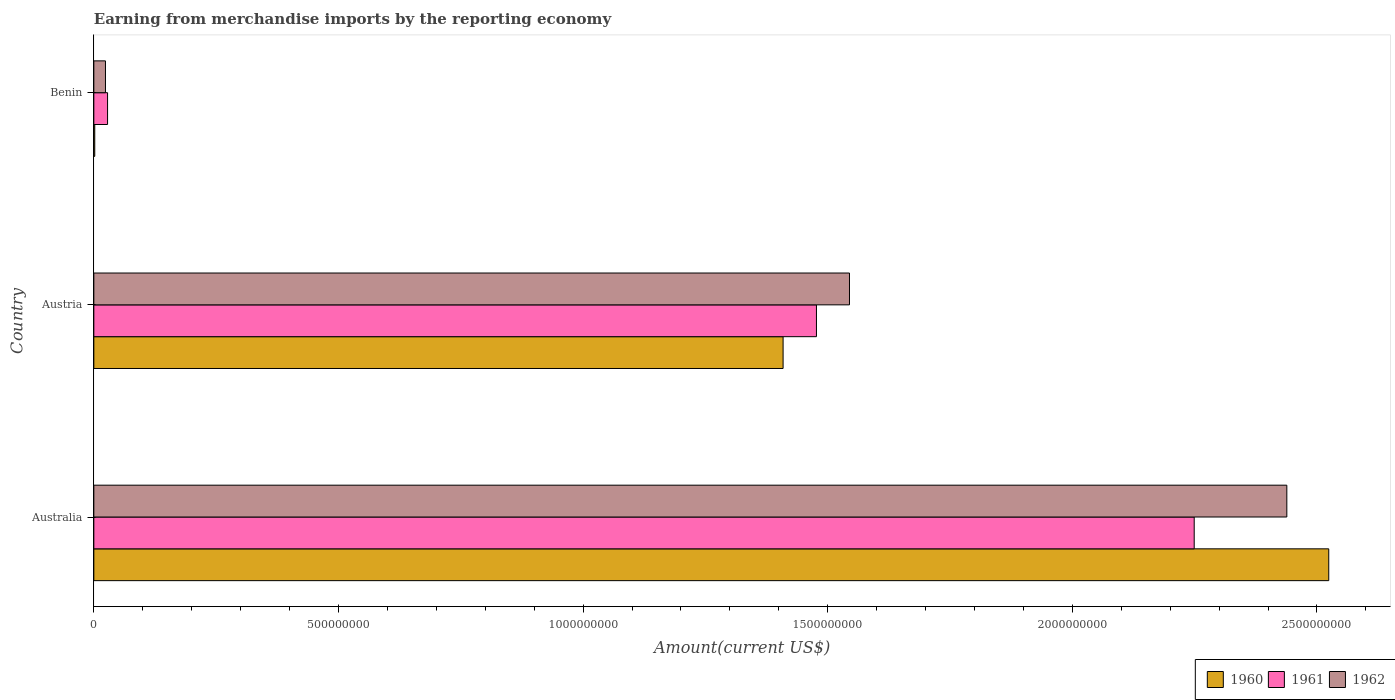Are the number of bars on each tick of the Y-axis equal?
Make the answer very short. Yes. How many bars are there on the 3rd tick from the top?
Provide a short and direct response. 3. How many bars are there on the 1st tick from the bottom?
Provide a succinct answer. 3. What is the label of the 2nd group of bars from the top?
Offer a very short reply. Austria. What is the amount earned from merchandise imports in 1961 in Benin?
Your response must be concise. 2.81e+07. Across all countries, what is the maximum amount earned from merchandise imports in 1962?
Offer a very short reply. 2.44e+09. Across all countries, what is the minimum amount earned from merchandise imports in 1961?
Provide a succinct answer. 2.81e+07. In which country was the amount earned from merchandise imports in 1960 maximum?
Give a very brief answer. Australia. In which country was the amount earned from merchandise imports in 1960 minimum?
Offer a very short reply. Benin. What is the total amount earned from merchandise imports in 1960 in the graph?
Ensure brevity in your answer.  3.93e+09. What is the difference between the amount earned from merchandise imports in 1962 in Australia and that in Benin?
Your answer should be very brief. 2.41e+09. What is the difference between the amount earned from merchandise imports in 1960 in Benin and the amount earned from merchandise imports in 1961 in Australia?
Provide a succinct answer. -2.25e+09. What is the average amount earned from merchandise imports in 1962 per country?
Ensure brevity in your answer.  1.34e+09. What is the difference between the amount earned from merchandise imports in 1961 and amount earned from merchandise imports in 1960 in Benin?
Your answer should be compact. 2.62e+07. In how many countries, is the amount earned from merchandise imports in 1961 greater than 200000000 US$?
Offer a terse response. 2. What is the ratio of the amount earned from merchandise imports in 1961 in Australia to that in Austria?
Provide a succinct answer. 1.52. Is the difference between the amount earned from merchandise imports in 1961 in Australia and Austria greater than the difference between the amount earned from merchandise imports in 1960 in Australia and Austria?
Your answer should be compact. No. What is the difference between the highest and the second highest amount earned from merchandise imports in 1960?
Your response must be concise. 1.12e+09. What is the difference between the highest and the lowest amount earned from merchandise imports in 1961?
Offer a terse response. 2.22e+09. Is the sum of the amount earned from merchandise imports in 1960 in Australia and Austria greater than the maximum amount earned from merchandise imports in 1961 across all countries?
Offer a terse response. Yes. Is it the case that in every country, the sum of the amount earned from merchandise imports in 1962 and amount earned from merchandise imports in 1960 is greater than the amount earned from merchandise imports in 1961?
Make the answer very short. No. What is the difference between two consecutive major ticks on the X-axis?
Keep it short and to the point. 5.00e+08. Where does the legend appear in the graph?
Keep it short and to the point. Bottom right. How many legend labels are there?
Keep it short and to the point. 3. How are the legend labels stacked?
Provide a short and direct response. Horizontal. What is the title of the graph?
Offer a very short reply. Earning from merchandise imports by the reporting economy. Does "1966" appear as one of the legend labels in the graph?
Your answer should be very brief. No. What is the label or title of the X-axis?
Provide a succinct answer. Amount(current US$). What is the Amount(current US$) in 1960 in Australia?
Offer a terse response. 2.52e+09. What is the Amount(current US$) in 1961 in Australia?
Provide a short and direct response. 2.25e+09. What is the Amount(current US$) in 1962 in Australia?
Give a very brief answer. 2.44e+09. What is the Amount(current US$) of 1960 in Austria?
Offer a very short reply. 1.41e+09. What is the Amount(current US$) of 1961 in Austria?
Make the answer very short. 1.48e+09. What is the Amount(current US$) of 1962 in Austria?
Your answer should be very brief. 1.54e+09. What is the Amount(current US$) in 1960 in Benin?
Provide a short and direct response. 1.90e+06. What is the Amount(current US$) of 1961 in Benin?
Ensure brevity in your answer.  2.81e+07. What is the Amount(current US$) of 1962 in Benin?
Give a very brief answer. 2.38e+07. Across all countries, what is the maximum Amount(current US$) of 1960?
Provide a short and direct response. 2.52e+09. Across all countries, what is the maximum Amount(current US$) of 1961?
Provide a succinct answer. 2.25e+09. Across all countries, what is the maximum Amount(current US$) in 1962?
Provide a succinct answer. 2.44e+09. Across all countries, what is the minimum Amount(current US$) of 1960?
Your response must be concise. 1.90e+06. Across all countries, what is the minimum Amount(current US$) in 1961?
Offer a very short reply. 2.81e+07. Across all countries, what is the minimum Amount(current US$) in 1962?
Provide a succinct answer. 2.38e+07. What is the total Amount(current US$) in 1960 in the graph?
Give a very brief answer. 3.93e+09. What is the total Amount(current US$) in 1961 in the graph?
Provide a succinct answer. 3.75e+09. What is the total Amount(current US$) in 1962 in the graph?
Your answer should be very brief. 4.01e+09. What is the difference between the Amount(current US$) of 1960 in Australia and that in Austria?
Make the answer very short. 1.12e+09. What is the difference between the Amount(current US$) of 1961 in Australia and that in Austria?
Make the answer very short. 7.72e+08. What is the difference between the Amount(current US$) of 1962 in Australia and that in Austria?
Your answer should be very brief. 8.94e+08. What is the difference between the Amount(current US$) of 1960 in Australia and that in Benin?
Provide a short and direct response. 2.52e+09. What is the difference between the Amount(current US$) of 1961 in Australia and that in Benin?
Ensure brevity in your answer.  2.22e+09. What is the difference between the Amount(current US$) of 1962 in Australia and that in Benin?
Make the answer very short. 2.41e+09. What is the difference between the Amount(current US$) in 1960 in Austria and that in Benin?
Keep it short and to the point. 1.41e+09. What is the difference between the Amount(current US$) of 1961 in Austria and that in Benin?
Provide a succinct answer. 1.45e+09. What is the difference between the Amount(current US$) in 1962 in Austria and that in Benin?
Make the answer very short. 1.52e+09. What is the difference between the Amount(current US$) in 1960 in Australia and the Amount(current US$) in 1961 in Austria?
Keep it short and to the point. 1.05e+09. What is the difference between the Amount(current US$) of 1960 in Australia and the Amount(current US$) of 1962 in Austria?
Keep it short and to the point. 9.80e+08. What is the difference between the Amount(current US$) in 1961 in Australia and the Amount(current US$) in 1962 in Austria?
Ensure brevity in your answer.  7.05e+08. What is the difference between the Amount(current US$) in 1960 in Australia and the Amount(current US$) in 1961 in Benin?
Give a very brief answer. 2.50e+09. What is the difference between the Amount(current US$) of 1960 in Australia and the Amount(current US$) of 1962 in Benin?
Your response must be concise. 2.50e+09. What is the difference between the Amount(current US$) in 1961 in Australia and the Amount(current US$) in 1962 in Benin?
Your answer should be very brief. 2.23e+09. What is the difference between the Amount(current US$) in 1960 in Austria and the Amount(current US$) in 1961 in Benin?
Offer a terse response. 1.38e+09. What is the difference between the Amount(current US$) in 1960 in Austria and the Amount(current US$) in 1962 in Benin?
Make the answer very short. 1.38e+09. What is the difference between the Amount(current US$) of 1961 in Austria and the Amount(current US$) of 1962 in Benin?
Make the answer very short. 1.45e+09. What is the average Amount(current US$) of 1960 per country?
Offer a terse response. 1.31e+09. What is the average Amount(current US$) of 1961 per country?
Ensure brevity in your answer.  1.25e+09. What is the average Amount(current US$) of 1962 per country?
Ensure brevity in your answer.  1.34e+09. What is the difference between the Amount(current US$) of 1960 and Amount(current US$) of 1961 in Australia?
Your answer should be compact. 2.75e+08. What is the difference between the Amount(current US$) in 1960 and Amount(current US$) in 1962 in Australia?
Make the answer very short. 8.57e+07. What is the difference between the Amount(current US$) in 1961 and Amount(current US$) in 1962 in Australia?
Your answer should be compact. -1.89e+08. What is the difference between the Amount(current US$) in 1960 and Amount(current US$) in 1961 in Austria?
Your answer should be compact. -6.82e+07. What is the difference between the Amount(current US$) of 1960 and Amount(current US$) of 1962 in Austria?
Make the answer very short. -1.36e+08. What is the difference between the Amount(current US$) in 1961 and Amount(current US$) in 1962 in Austria?
Provide a succinct answer. -6.75e+07. What is the difference between the Amount(current US$) in 1960 and Amount(current US$) in 1961 in Benin?
Provide a short and direct response. -2.62e+07. What is the difference between the Amount(current US$) in 1960 and Amount(current US$) in 1962 in Benin?
Keep it short and to the point. -2.19e+07. What is the difference between the Amount(current US$) in 1961 and Amount(current US$) in 1962 in Benin?
Offer a very short reply. 4.30e+06. What is the ratio of the Amount(current US$) in 1960 in Australia to that in Austria?
Your answer should be compact. 1.79. What is the ratio of the Amount(current US$) in 1961 in Australia to that in Austria?
Your answer should be very brief. 1.52. What is the ratio of the Amount(current US$) of 1962 in Australia to that in Austria?
Offer a terse response. 1.58. What is the ratio of the Amount(current US$) of 1960 in Australia to that in Benin?
Keep it short and to the point. 1328.45. What is the ratio of the Amount(current US$) of 1961 in Australia to that in Benin?
Keep it short and to the point. 80.04. What is the ratio of the Amount(current US$) of 1962 in Australia to that in Benin?
Ensure brevity in your answer.  102.45. What is the ratio of the Amount(current US$) of 1960 in Austria to that in Benin?
Keep it short and to the point. 741.47. What is the ratio of the Amount(current US$) in 1961 in Austria to that in Benin?
Give a very brief answer. 52.56. What is the ratio of the Amount(current US$) in 1962 in Austria to that in Benin?
Your answer should be very brief. 64.89. What is the difference between the highest and the second highest Amount(current US$) of 1960?
Your answer should be very brief. 1.12e+09. What is the difference between the highest and the second highest Amount(current US$) of 1961?
Make the answer very short. 7.72e+08. What is the difference between the highest and the second highest Amount(current US$) of 1962?
Provide a short and direct response. 8.94e+08. What is the difference between the highest and the lowest Amount(current US$) in 1960?
Ensure brevity in your answer.  2.52e+09. What is the difference between the highest and the lowest Amount(current US$) of 1961?
Give a very brief answer. 2.22e+09. What is the difference between the highest and the lowest Amount(current US$) of 1962?
Your answer should be compact. 2.41e+09. 